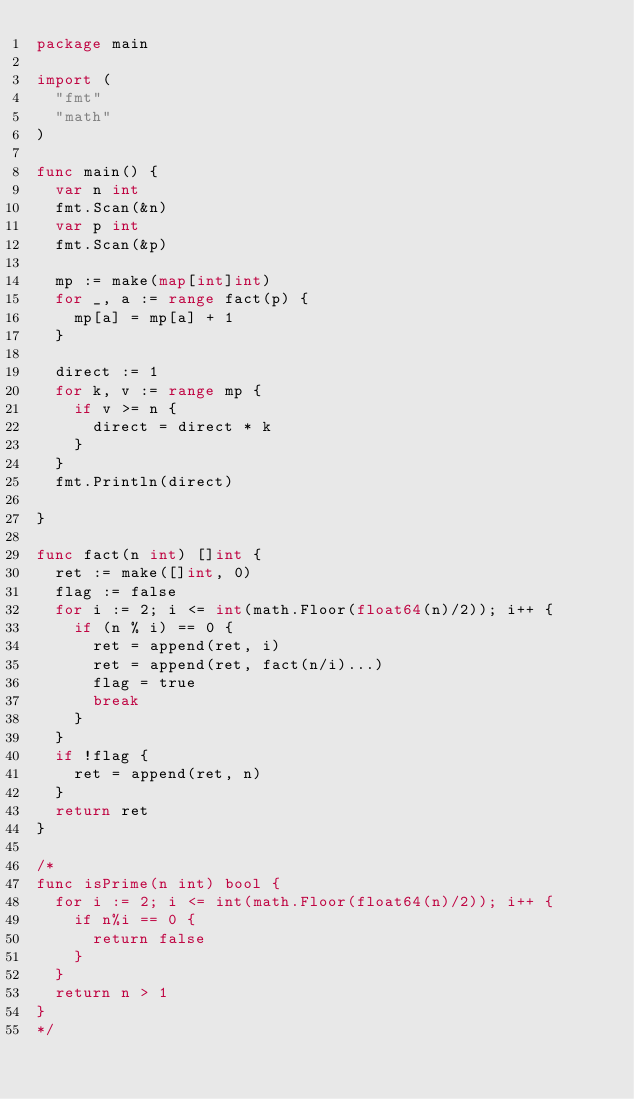Convert code to text. <code><loc_0><loc_0><loc_500><loc_500><_Go_>package main

import (
	"fmt"
	"math"
)

func main() {
	var n int
	fmt.Scan(&n)
	var p int
	fmt.Scan(&p)

	mp := make(map[int]int)
	for _, a := range fact(p) {
		mp[a] = mp[a] + 1
	}

	direct := 1
	for k, v := range mp {
		if v >= n {
			direct = direct * k
		}
	}
	fmt.Println(direct)

}

func fact(n int) []int {
	ret := make([]int, 0)
	flag := false
	for i := 2; i <= int(math.Floor(float64(n)/2)); i++ {
		if (n % i) == 0 {
			ret = append(ret, i)
			ret = append(ret, fact(n/i)...)
			flag = true
			break
		}
	}
	if !flag {
		ret = append(ret, n)
	}
	return ret
}

/*
func isPrime(n int) bool {
	for i := 2; i <= int(math.Floor(float64(n)/2)); i++ {
		if n%i == 0 {
			return false
		}
	}
	return n > 1
}
*/
</code> 